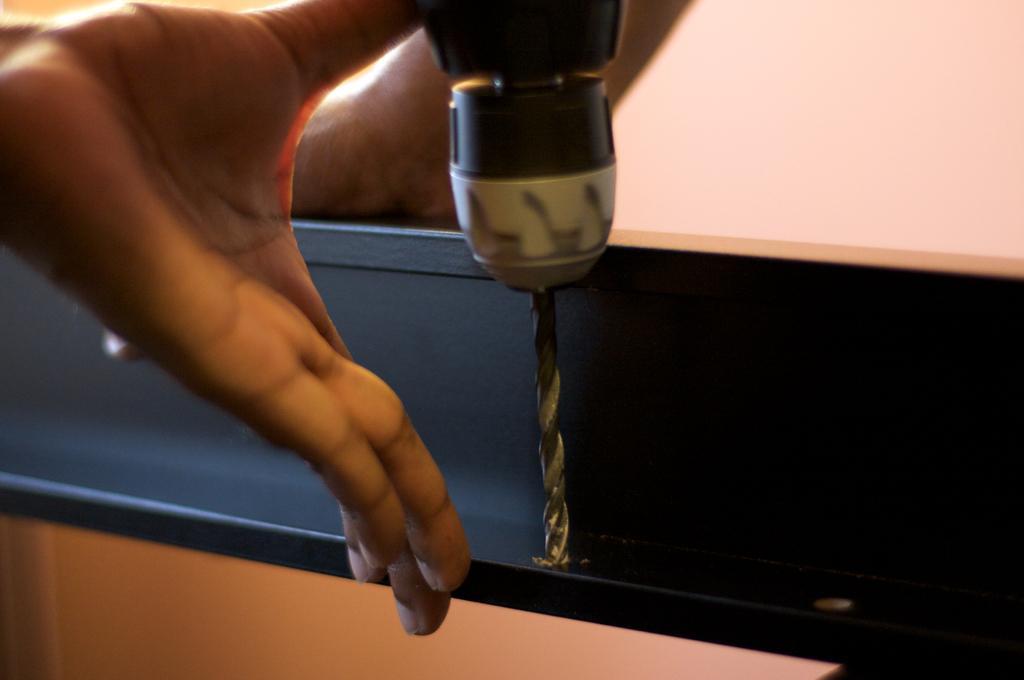Can you describe this image briefly? In the picture we can find a hand and a drilling machine is dripping something on the object. 